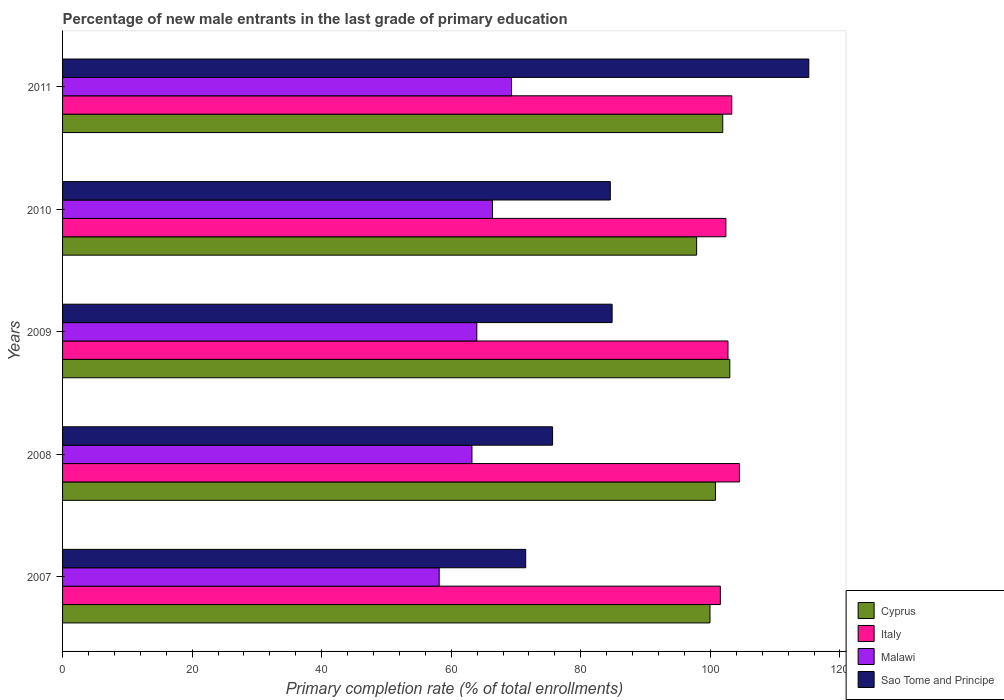How many different coloured bars are there?
Your response must be concise. 4. Are the number of bars per tick equal to the number of legend labels?
Your answer should be very brief. Yes. How many bars are there on the 3rd tick from the top?
Your answer should be very brief. 4. How many bars are there on the 3rd tick from the bottom?
Provide a succinct answer. 4. What is the percentage of new male entrants in Italy in 2007?
Keep it short and to the point. 101.54. Across all years, what is the maximum percentage of new male entrants in Sao Tome and Principe?
Offer a terse response. 115.2. Across all years, what is the minimum percentage of new male entrants in Sao Tome and Principe?
Your answer should be very brief. 71.49. In which year was the percentage of new male entrants in Italy minimum?
Your answer should be very brief. 2007. What is the total percentage of new male entrants in Malawi in the graph?
Keep it short and to the point. 320.95. What is the difference between the percentage of new male entrants in Sao Tome and Principe in 2008 and that in 2010?
Provide a short and direct response. -8.92. What is the difference between the percentage of new male entrants in Malawi in 2008 and the percentage of new male entrants in Cyprus in 2007?
Your answer should be very brief. -36.75. What is the average percentage of new male entrants in Cyprus per year?
Give a very brief answer. 100.7. In the year 2008, what is the difference between the percentage of new male entrants in Italy and percentage of new male entrants in Malawi?
Keep it short and to the point. 41.29. In how many years, is the percentage of new male entrants in Malawi greater than 88 %?
Make the answer very short. 0. What is the ratio of the percentage of new male entrants in Malawi in 2010 to that in 2011?
Make the answer very short. 0.96. Is the percentage of new male entrants in Italy in 2008 less than that in 2010?
Ensure brevity in your answer.  No. Is the difference between the percentage of new male entrants in Italy in 2008 and 2009 greater than the difference between the percentage of new male entrants in Malawi in 2008 and 2009?
Offer a very short reply. Yes. What is the difference between the highest and the second highest percentage of new male entrants in Cyprus?
Give a very brief answer. 1.09. What is the difference between the highest and the lowest percentage of new male entrants in Cyprus?
Offer a terse response. 5.12. In how many years, is the percentage of new male entrants in Sao Tome and Principe greater than the average percentage of new male entrants in Sao Tome and Principe taken over all years?
Offer a very short reply. 1. Is the sum of the percentage of new male entrants in Cyprus in 2010 and 2011 greater than the maximum percentage of new male entrants in Sao Tome and Principe across all years?
Offer a very short reply. Yes. What does the 1st bar from the top in 2010 represents?
Offer a very short reply. Sao Tome and Principe. What does the 4th bar from the bottom in 2009 represents?
Offer a terse response. Sao Tome and Principe. How many bars are there?
Your answer should be compact. 20. Are all the bars in the graph horizontal?
Provide a succinct answer. Yes. What is the difference between two consecutive major ticks on the X-axis?
Ensure brevity in your answer.  20. Does the graph contain any zero values?
Give a very brief answer. No. Does the graph contain grids?
Keep it short and to the point. No. How many legend labels are there?
Offer a terse response. 4. What is the title of the graph?
Ensure brevity in your answer.  Percentage of new male entrants in the last grade of primary education. Does "Rwanda" appear as one of the legend labels in the graph?
Keep it short and to the point. No. What is the label or title of the X-axis?
Your response must be concise. Primary completion rate (% of total enrollments). What is the label or title of the Y-axis?
Your answer should be very brief. Years. What is the Primary completion rate (% of total enrollments) in Cyprus in 2007?
Your answer should be compact. 99.94. What is the Primary completion rate (% of total enrollments) of Italy in 2007?
Ensure brevity in your answer.  101.54. What is the Primary completion rate (% of total enrollments) of Malawi in 2007?
Provide a short and direct response. 58.14. What is the Primary completion rate (% of total enrollments) in Sao Tome and Principe in 2007?
Keep it short and to the point. 71.49. What is the Primary completion rate (% of total enrollments) of Cyprus in 2008?
Provide a succinct answer. 100.79. What is the Primary completion rate (% of total enrollments) of Italy in 2008?
Provide a succinct answer. 104.49. What is the Primary completion rate (% of total enrollments) in Malawi in 2008?
Ensure brevity in your answer.  63.2. What is the Primary completion rate (% of total enrollments) in Sao Tome and Principe in 2008?
Your answer should be very brief. 75.64. What is the Primary completion rate (% of total enrollments) of Cyprus in 2009?
Give a very brief answer. 103. What is the Primary completion rate (% of total enrollments) of Italy in 2009?
Make the answer very short. 102.72. What is the Primary completion rate (% of total enrollments) of Malawi in 2009?
Give a very brief answer. 63.95. What is the Primary completion rate (% of total enrollments) in Sao Tome and Principe in 2009?
Provide a short and direct response. 84.83. What is the Primary completion rate (% of total enrollments) of Cyprus in 2010?
Give a very brief answer. 97.88. What is the Primary completion rate (% of total enrollments) in Italy in 2010?
Provide a short and direct response. 102.4. What is the Primary completion rate (% of total enrollments) in Malawi in 2010?
Your answer should be very brief. 66.37. What is the Primary completion rate (% of total enrollments) of Sao Tome and Principe in 2010?
Your answer should be very brief. 84.56. What is the Primary completion rate (% of total enrollments) in Cyprus in 2011?
Provide a short and direct response. 101.91. What is the Primary completion rate (% of total enrollments) in Italy in 2011?
Keep it short and to the point. 103.31. What is the Primary completion rate (% of total enrollments) in Malawi in 2011?
Offer a terse response. 69.3. What is the Primary completion rate (% of total enrollments) of Sao Tome and Principe in 2011?
Give a very brief answer. 115.2. Across all years, what is the maximum Primary completion rate (% of total enrollments) in Cyprus?
Ensure brevity in your answer.  103. Across all years, what is the maximum Primary completion rate (% of total enrollments) in Italy?
Make the answer very short. 104.49. Across all years, what is the maximum Primary completion rate (% of total enrollments) in Malawi?
Give a very brief answer. 69.3. Across all years, what is the maximum Primary completion rate (% of total enrollments) in Sao Tome and Principe?
Offer a terse response. 115.2. Across all years, what is the minimum Primary completion rate (% of total enrollments) of Cyprus?
Keep it short and to the point. 97.88. Across all years, what is the minimum Primary completion rate (% of total enrollments) in Italy?
Provide a short and direct response. 101.54. Across all years, what is the minimum Primary completion rate (% of total enrollments) in Malawi?
Offer a very short reply. 58.14. Across all years, what is the minimum Primary completion rate (% of total enrollments) in Sao Tome and Principe?
Make the answer very short. 71.49. What is the total Primary completion rate (% of total enrollments) of Cyprus in the graph?
Offer a very short reply. 503.52. What is the total Primary completion rate (% of total enrollments) in Italy in the graph?
Your response must be concise. 514.46. What is the total Primary completion rate (% of total enrollments) in Malawi in the graph?
Keep it short and to the point. 320.95. What is the total Primary completion rate (% of total enrollments) of Sao Tome and Principe in the graph?
Make the answer very short. 431.73. What is the difference between the Primary completion rate (% of total enrollments) of Cyprus in 2007 and that in 2008?
Make the answer very short. -0.84. What is the difference between the Primary completion rate (% of total enrollments) in Italy in 2007 and that in 2008?
Give a very brief answer. -2.95. What is the difference between the Primary completion rate (% of total enrollments) in Malawi in 2007 and that in 2008?
Offer a terse response. -5.06. What is the difference between the Primary completion rate (% of total enrollments) in Sao Tome and Principe in 2007 and that in 2008?
Your answer should be very brief. -4.15. What is the difference between the Primary completion rate (% of total enrollments) of Cyprus in 2007 and that in 2009?
Offer a very short reply. -3.06. What is the difference between the Primary completion rate (% of total enrollments) in Italy in 2007 and that in 2009?
Your response must be concise. -1.18. What is the difference between the Primary completion rate (% of total enrollments) in Malawi in 2007 and that in 2009?
Provide a short and direct response. -5.81. What is the difference between the Primary completion rate (% of total enrollments) in Sao Tome and Principe in 2007 and that in 2009?
Give a very brief answer. -13.34. What is the difference between the Primary completion rate (% of total enrollments) of Cyprus in 2007 and that in 2010?
Offer a very short reply. 2.06. What is the difference between the Primary completion rate (% of total enrollments) of Italy in 2007 and that in 2010?
Offer a very short reply. -0.85. What is the difference between the Primary completion rate (% of total enrollments) in Malawi in 2007 and that in 2010?
Your answer should be very brief. -8.23. What is the difference between the Primary completion rate (% of total enrollments) of Sao Tome and Principe in 2007 and that in 2010?
Provide a short and direct response. -13.06. What is the difference between the Primary completion rate (% of total enrollments) of Cyprus in 2007 and that in 2011?
Ensure brevity in your answer.  -1.97. What is the difference between the Primary completion rate (% of total enrollments) of Italy in 2007 and that in 2011?
Your response must be concise. -1.76. What is the difference between the Primary completion rate (% of total enrollments) in Malawi in 2007 and that in 2011?
Your answer should be very brief. -11.16. What is the difference between the Primary completion rate (% of total enrollments) of Sao Tome and Principe in 2007 and that in 2011?
Offer a terse response. -43.7. What is the difference between the Primary completion rate (% of total enrollments) of Cyprus in 2008 and that in 2009?
Provide a succinct answer. -2.22. What is the difference between the Primary completion rate (% of total enrollments) in Italy in 2008 and that in 2009?
Offer a very short reply. 1.77. What is the difference between the Primary completion rate (% of total enrollments) of Malawi in 2008 and that in 2009?
Provide a succinct answer. -0.75. What is the difference between the Primary completion rate (% of total enrollments) of Sao Tome and Principe in 2008 and that in 2009?
Your response must be concise. -9.19. What is the difference between the Primary completion rate (% of total enrollments) in Cyprus in 2008 and that in 2010?
Make the answer very short. 2.91. What is the difference between the Primary completion rate (% of total enrollments) of Italy in 2008 and that in 2010?
Make the answer very short. 2.09. What is the difference between the Primary completion rate (% of total enrollments) of Malawi in 2008 and that in 2010?
Offer a terse response. -3.17. What is the difference between the Primary completion rate (% of total enrollments) in Sao Tome and Principe in 2008 and that in 2010?
Your answer should be very brief. -8.92. What is the difference between the Primary completion rate (% of total enrollments) in Cyprus in 2008 and that in 2011?
Give a very brief answer. -1.12. What is the difference between the Primary completion rate (% of total enrollments) of Italy in 2008 and that in 2011?
Make the answer very short. 1.18. What is the difference between the Primary completion rate (% of total enrollments) in Malawi in 2008 and that in 2011?
Offer a terse response. -6.1. What is the difference between the Primary completion rate (% of total enrollments) in Sao Tome and Principe in 2008 and that in 2011?
Offer a very short reply. -39.55. What is the difference between the Primary completion rate (% of total enrollments) in Cyprus in 2009 and that in 2010?
Offer a very short reply. 5.12. What is the difference between the Primary completion rate (% of total enrollments) in Italy in 2009 and that in 2010?
Offer a terse response. 0.32. What is the difference between the Primary completion rate (% of total enrollments) in Malawi in 2009 and that in 2010?
Offer a terse response. -2.42. What is the difference between the Primary completion rate (% of total enrollments) in Sao Tome and Principe in 2009 and that in 2010?
Give a very brief answer. 0.28. What is the difference between the Primary completion rate (% of total enrollments) of Cyprus in 2009 and that in 2011?
Your answer should be compact. 1.09. What is the difference between the Primary completion rate (% of total enrollments) in Italy in 2009 and that in 2011?
Keep it short and to the point. -0.59. What is the difference between the Primary completion rate (% of total enrollments) of Malawi in 2009 and that in 2011?
Offer a terse response. -5.35. What is the difference between the Primary completion rate (% of total enrollments) in Sao Tome and Principe in 2009 and that in 2011?
Your answer should be very brief. -30.36. What is the difference between the Primary completion rate (% of total enrollments) of Cyprus in 2010 and that in 2011?
Your answer should be very brief. -4.03. What is the difference between the Primary completion rate (% of total enrollments) of Italy in 2010 and that in 2011?
Keep it short and to the point. -0.91. What is the difference between the Primary completion rate (% of total enrollments) of Malawi in 2010 and that in 2011?
Offer a terse response. -2.93. What is the difference between the Primary completion rate (% of total enrollments) in Sao Tome and Principe in 2010 and that in 2011?
Your answer should be very brief. -30.64. What is the difference between the Primary completion rate (% of total enrollments) in Cyprus in 2007 and the Primary completion rate (% of total enrollments) in Italy in 2008?
Offer a terse response. -4.54. What is the difference between the Primary completion rate (% of total enrollments) of Cyprus in 2007 and the Primary completion rate (% of total enrollments) of Malawi in 2008?
Your answer should be compact. 36.75. What is the difference between the Primary completion rate (% of total enrollments) of Cyprus in 2007 and the Primary completion rate (% of total enrollments) of Sao Tome and Principe in 2008?
Your answer should be very brief. 24.3. What is the difference between the Primary completion rate (% of total enrollments) in Italy in 2007 and the Primary completion rate (% of total enrollments) in Malawi in 2008?
Your answer should be very brief. 38.35. What is the difference between the Primary completion rate (% of total enrollments) in Italy in 2007 and the Primary completion rate (% of total enrollments) in Sao Tome and Principe in 2008?
Offer a very short reply. 25.9. What is the difference between the Primary completion rate (% of total enrollments) in Malawi in 2007 and the Primary completion rate (% of total enrollments) in Sao Tome and Principe in 2008?
Your answer should be compact. -17.51. What is the difference between the Primary completion rate (% of total enrollments) in Cyprus in 2007 and the Primary completion rate (% of total enrollments) in Italy in 2009?
Make the answer very short. -2.78. What is the difference between the Primary completion rate (% of total enrollments) of Cyprus in 2007 and the Primary completion rate (% of total enrollments) of Malawi in 2009?
Provide a succinct answer. 36. What is the difference between the Primary completion rate (% of total enrollments) of Cyprus in 2007 and the Primary completion rate (% of total enrollments) of Sao Tome and Principe in 2009?
Ensure brevity in your answer.  15.11. What is the difference between the Primary completion rate (% of total enrollments) in Italy in 2007 and the Primary completion rate (% of total enrollments) in Malawi in 2009?
Your answer should be very brief. 37.59. What is the difference between the Primary completion rate (% of total enrollments) in Italy in 2007 and the Primary completion rate (% of total enrollments) in Sao Tome and Principe in 2009?
Keep it short and to the point. 16.71. What is the difference between the Primary completion rate (% of total enrollments) of Malawi in 2007 and the Primary completion rate (% of total enrollments) of Sao Tome and Principe in 2009?
Ensure brevity in your answer.  -26.7. What is the difference between the Primary completion rate (% of total enrollments) of Cyprus in 2007 and the Primary completion rate (% of total enrollments) of Italy in 2010?
Provide a short and direct response. -2.45. What is the difference between the Primary completion rate (% of total enrollments) of Cyprus in 2007 and the Primary completion rate (% of total enrollments) of Malawi in 2010?
Your answer should be very brief. 33.58. What is the difference between the Primary completion rate (% of total enrollments) in Cyprus in 2007 and the Primary completion rate (% of total enrollments) in Sao Tome and Principe in 2010?
Your answer should be compact. 15.39. What is the difference between the Primary completion rate (% of total enrollments) of Italy in 2007 and the Primary completion rate (% of total enrollments) of Malawi in 2010?
Offer a very short reply. 35.17. What is the difference between the Primary completion rate (% of total enrollments) in Italy in 2007 and the Primary completion rate (% of total enrollments) in Sao Tome and Principe in 2010?
Give a very brief answer. 16.98. What is the difference between the Primary completion rate (% of total enrollments) of Malawi in 2007 and the Primary completion rate (% of total enrollments) of Sao Tome and Principe in 2010?
Make the answer very short. -26.42. What is the difference between the Primary completion rate (% of total enrollments) in Cyprus in 2007 and the Primary completion rate (% of total enrollments) in Italy in 2011?
Offer a terse response. -3.36. What is the difference between the Primary completion rate (% of total enrollments) in Cyprus in 2007 and the Primary completion rate (% of total enrollments) in Malawi in 2011?
Ensure brevity in your answer.  30.64. What is the difference between the Primary completion rate (% of total enrollments) of Cyprus in 2007 and the Primary completion rate (% of total enrollments) of Sao Tome and Principe in 2011?
Provide a succinct answer. -15.25. What is the difference between the Primary completion rate (% of total enrollments) of Italy in 2007 and the Primary completion rate (% of total enrollments) of Malawi in 2011?
Ensure brevity in your answer.  32.24. What is the difference between the Primary completion rate (% of total enrollments) of Italy in 2007 and the Primary completion rate (% of total enrollments) of Sao Tome and Principe in 2011?
Give a very brief answer. -13.65. What is the difference between the Primary completion rate (% of total enrollments) of Malawi in 2007 and the Primary completion rate (% of total enrollments) of Sao Tome and Principe in 2011?
Provide a short and direct response. -57.06. What is the difference between the Primary completion rate (% of total enrollments) of Cyprus in 2008 and the Primary completion rate (% of total enrollments) of Italy in 2009?
Offer a very short reply. -1.93. What is the difference between the Primary completion rate (% of total enrollments) in Cyprus in 2008 and the Primary completion rate (% of total enrollments) in Malawi in 2009?
Ensure brevity in your answer.  36.84. What is the difference between the Primary completion rate (% of total enrollments) of Cyprus in 2008 and the Primary completion rate (% of total enrollments) of Sao Tome and Principe in 2009?
Make the answer very short. 15.95. What is the difference between the Primary completion rate (% of total enrollments) in Italy in 2008 and the Primary completion rate (% of total enrollments) in Malawi in 2009?
Make the answer very short. 40.54. What is the difference between the Primary completion rate (% of total enrollments) of Italy in 2008 and the Primary completion rate (% of total enrollments) of Sao Tome and Principe in 2009?
Make the answer very short. 19.65. What is the difference between the Primary completion rate (% of total enrollments) of Malawi in 2008 and the Primary completion rate (% of total enrollments) of Sao Tome and Principe in 2009?
Your response must be concise. -21.64. What is the difference between the Primary completion rate (% of total enrollments) in Cyprus in 2008 and the Primary completion rate (% of total enrollments) in Italy in 2010?
Provide a succinct answer. -1.61. What is the difference between the Primary completion rate (% of total enrollments) of Cyprus in 2008 and the Primary completion rate (% of total enrollments) of Malawi in 2010?
Your answer should be compact. 34.42. What is the difference between the Primary completion rate (% of total enrollments) of Cyprus in 2008 and the Primary completion rate (% of total enrollments) of Sao Tome and Principe in 2010?
Make the answer very short. 16.23. What is the difference between the Primary completion rate (% of total enrollments) in Italy in 2008 and the Primary completion rate (% of total enrollments) in Malawi in 2010?
Provide a short and direct response. 38.12. What is the difference between the Primary completion rate (% of total enrollments) of Italy in 2008 and the Primary completion rate (% of total enrollments) of Sao Tome and Principe in 2010?
Your answer should be very brief. 19.93. What is the difference between the Primary completion rate (% of total enrollments) in Malawi in 2008 and the Primary completion rate (% of total enrollments) in Sao Tome and Principe in 2010?
Keep it short and to the point. -21.36. What is the difference between the Primary completion rate (% of total enrollments) in Cyprus in 2008 and the Primary completion rate (% of total enrollments) in Italy in 2011?
Your answer should be compact. -2.52. What is the difference between the Primary completion rate (% of total enrollments) of Cyprus in 2008 and the Primary completion rate (% of total enrollments) of Malawi in 2011?
Your answer should be compact. 31.49. What is the difference between the Primary completion rate (% of total enrollments) of Cyprus in 2008 and the Primary completion rate (% of total enrollments) of Sao Tome and Principe in 2011?
Make the answer very short. -14.41. What is the difference between the Primary completion rate (% of total enrollments) of Italy in 2008 and the Primary completion rate (% of total enrollments) of Malawi in 2011?
Offer a very short reply. 35.19. What is the difference between the Primary completion rate (% of total enrollments) in Italy in 2008 and the Primary completion rate (% of total enrollments) in Sao Tome and Principe in 2011?
Offer a terse response. -10.71. What is the difference between the Primary completion rate (% of total enrollments) of Malawi in 2008 and the Primary completion rate (% of total enrollments) of Sao Tome and Principe in 2011?
Your answer should be very brief. -52. What is the difference between the Primary completion rate (% of total enrollments) of Cyprus in 2009 and the Primary completion rate (% of total enrollments) of Italy in 2010?
Offer a very short reply. 0.6. What is the difference between the Primary completion rate (% of total enrollments) of Cyprus in 2009 and the Primary completion rate (% of total enrollments) of Malawi in 2010?
Provide a short and direct response. 36.63. What is the difference between the Primary completion rate (% of total enrollments) in Cyprus in 2009 and the Primary completion rate (% of total enrollments) in Sao Tome and Principe in 2010?
Offer a terse response. 18.44. What is the difference between the Primary completion rate (% of total enrollments) of Italy in 2009 and the Primary completion rate (% of total enrollments) of Malawi in 2010?
Give a very brief answer. 36.35. What is the difference between the Primary completion rate (% of total enrollments) in Italy in 2009 and the Primary completion rate (% of total enrollments) in Sao Tome and Principe in 2010?
Make the answer very short. 18.16. What is the difference between the Primary completion rate (% of total enrollments) of Malawi in 2009 and the Primary completion rate (% of total enrollments) of Sao Tome and Principe in 2010?
Provide a succinct answer. -20.61. What is the difference between the Primary completion rate (% of total enrollments) in Cyprus in 2009 and the Primary completion rate (% of total enrollments) in Italy in 2011?
Provide a short and direct response. -0.31. What is the difference between the Primary completion rate (% of total enrollments) of Cyprus in 2009 and the Primary completion rate (% of total enrollments) of Malawi in 2011?
Give a very brief answer. 33.7. What is the difference between the Primary completion rate (% of total enrollments) of Cyprus in 2009 and the Primary completion rate (% of total enrollments) of Sao Tome and Principe in 2011?
Provide a succinct answer. -12.19. What is the difference between the Primary completion rate (% of total enrollments) of Italy in 2009 and the Primary completion rate (% of total enrollments) of Malawi in 2011?
Provide a short and direct response. 33.42. What is the difference between the Primary completion rate (% of total enrollments) in Italy in 2009 and the Primary completion rate (% of total enrollments) in Sao Tome and Principe in 2011?
Ensure brevity in your answer.  -12.48. What is the difference between the Primary completion rate (% of total enrollments) in Malawi in 2009 and the Primary completion rate (% of total enrollments) in Sao Tome and Principe in 2011?
Make the answer very short. -51.25. What is the difference between the Primary completion rate (% of total enrollments) of Cyprus in 2010 and the Primary completion rate (% of total enrollments) of Italy in 2011?
Ensure brevity in your answer.  -5.43. What is the difference between the Primary completion rate (% of total enrollments) of Cyprus in 2010 and the Primary completion rate (% of total enrollments) of Malawi in 2011?
Your response must be concise. 28.58. What is the difference between the Primary completion rate (% of total enrollments) of Cyprus in 2010 and the Primary completion rate (% of total enrollments) of Sao Tome and Principe in 2011?
Give a very brief answer. -17.32. What is the difference between the Primary completion rate (% of total enrollments) in Italy in 2010 and the Primary completion rate (% of total enrollments) in Malawi in 2011?
Ensure brevity in your answer.  33.1. What is the difference between the Primary completion rate (% of total enrollments) of Italy in 2010 and the Primary completion rate (% of total enrollments) of Sao Tome and Principe in 2011?
Provide a succinct answer. -12.8. What is the difference between the Primary completion rate (% of total enrollments) in Malawi in 2010 and the Primary completion rate (% of total enrollments) in Sao Tome and Principe in 2011?
Offer a terse response. -48.83. What is the average Primary completion rate (% of total enrollments) of Cyprus per year?
Provide a succinct answer. 100.7. What is the average Primary completion rate (% of total enrollments) in Italy per year?
Provide a short and direct response. 102.89. What is the average Primary completion rate (% of total enrollments) in Malawi per year?
Offer a very short reply. 64.19. What is the average Primary completion rate (% of total enrollments) in Sao Tome and Principe per year?
Make the answer very short. 86.35. In the year 2007, what is the difference between the Primary completion rate (% of total enrollments) in Cyprus and Primary completion rate (% of total enrollments) in Italy?
Make the answer very short. -1.6. In the year 2007, what is the difference between the Primary completion rate (% of total enrollments) of Cyprus and Primary completion rate (% of total enrollments) of Malawi?
Provide a short and direct response. 41.81. In the year 2007, what is the difference between the Primary completion rate (% of total enrollments) of Cyprus and Primary completion rate (% of total enrollments) of Sao Tome and Principe?
Make the answer very short. 28.45. In the year 2007, what is the difference between the Primary completion rate (% of total enrollments) of Italy and Primary completion rate (% of total enrollments) of Malawi?
Make the answer very short. 43.41. In the year 2007, what is the difference between the Primary completion rate (% of total enrollments) in Italy and Primary completion rate (% of total enrollments) in Sao Tome and Principe?
Your response must be concise. 30.05. In the year 2007, what is the difference between the Primary completion rate (% of total enrollments) in Malawi and Primary completion rate (% of total enrollments) in Sao Tome and Principe?
Your answer should be very brief. -13.36. In the year 2008, what is the difference between the Primary completion rate (% of total enrollments) in Cyprus and Primary completion rate (% of total enrollments) in Italy?
Ensure brevity in your answer.  -3.7. In the year 2008, what is the difference between the Primary completion rate (% of total enrollments) of Cyprus and Primary completion rate (% of total enrollments) of Malawi?
Make the answer very short. 37.59. In the year 2008, what is the difference between the Primary completion rate (% of total enrollments) of Cyprus and Primary completion rate (% of total enrollments) of Sao Tome and Principe?
Your response must be concise. 25.14. In the year 2008, what is the difference between the Primary completion rate (% of total enrollments) in Italy and Primary completion rate (% of total enrollments) in Malawi?
Offer a terse response. 41.29. In the year 2008, what is the difference between the Primary completion rate (% of total enrollments) in Italy and Primary completion rate (% of total enrollments) in Sao Tome and Principe?
Your answer should be compact. 28.85. In the year 2008, what is the difference between the Primary completion rate (% of total enrollments) of Malawi and Primary completion rate (% of total enrollments) of Sao Tome and Principe?
Your answer should be compact. -12.45. In the year 2009, what is the difference between the Primary completion rate (% of total enrollments) of Cyprus and Primary completion rate (% of total enrollments) of Italy?
Make the answer very short. 0.28. In the year 2009, what is the difference between the Primary completion rate (% of total enrollments) of Cyprus and Primary completion rate (% of total enrollments) of Malawi?
Offer a very short reply. 39.05. In the year 2009, what is the difference between the Primary completion rate (% of total enrollments) of Cyprus and Primary completion rate (% of total enrollments) of Sao Tome and Principe?
Provide a succinct answer. 18.17. In the year 2009, what is the difference between the Primary completion rate (% of total enrollments) of Italy and Primary completion rate (% of total enrollments) of Malawi?
Ensure brevity in your answer.  38.77. In the year 2009, what is the difference between the Primary completion rate (% of total enrollments) in Italy and Primary completion rate (% of total enrollments) in Sao Tome and Principe?
Offer a very short reply. 17.89. In the year 2009, what is the difference between the Primary completion rate (% of total enrollments) of Malawi and Primary completion rate (% of total enrollments) of Sao Tome and Principe?
Make the answer very short. -20.89. In the year 2010, what is the difference between the Primary completion rate (% of total enrollments) in Cyprus and Primary completion rate (% of total enrollments) in Italy?
Keep it short and to the point. -4.52. In the year 2010, what is the difference between the Primary completion rate (% of total enrollments) in Cyprus and Primary completion rate (% of total enrollments) in Malawi?
Your answer should be compact. 31.51. In the year 2010, what is the difference between the Primary completion rate (% of total enrollments) of Cyprus and Primary completion rate (% of total enrollments) of Sao Tome and Principe?
Give a very brief answer. 13.32. In the year 2010, what is the difference between the Primary completion rate (% of total enrollments) of Italy and Primary completion rate (% of total enrollments) of Malawi?
Offer a terse response. 36.03. In the year 2010, what is the difference between the Primary completion rate (% of total enrollments) of Italy and Primary completion rate (% of total enrollments) of Sao Tome and Principe?
Offer a very short reply. 17.84. In the year 2010, what is the difference between the Primary completion rate (% of total enrollments) in Malawi and Primary completion rate (% of total enrollments) in Sao Tome and Principe?
Offer a very short reply. -18.19. In the year 2011, what is the difference between the Primary completion rate (% of total enrollments) of Cyprus and Primary completion rate (% of total enrollments) of Italy?
Give a very brief answer. -1.4. In the year 2011, what is the difference between the Primary completion rate (% of total enrollments) in Cyprus and Primary completion rate (% of total enrollments) in Malawi?
Make the answer very short. 32.61. In the year 2011, what is the difference between the Primary completion rate (% of total enrollments) in Cyprus and Primary completion rate (% of total enrollments) in Sao Tome and Principe?
Make the answer very short. -13.29. In the year 2011, what is the difference between the Primary completion rate (% of total enrollments) in Italy and Primary completion rate (% of total enrollments) in Malawi?
Provide a short and direct response. 34.01. In the year 2011, what is the difference between the Primary completion rate (% of total enrollments) of Italy and Primary completion rate (% of total enrollments) of Sao Tome and Principe?
Your response must be concise. -11.89. In the year 2011, what is the difference between the Primary completion rate (% of total enrollments) of Malawi and Primary completion rate (% of total enrollments) of Sao Tome and Principe?
Keep it short and to the point. -45.9. What is the ratio of the Primary completion rate (% of total enrollments) of Cyprus in 2007 to that in 2008?
Offer a terse response. 0.99. What is the ratio of the Primary completion rate (% of total enrollments) of Italy in 2007 to that in 2008?
Your response must be concise. 0.97. What is the ratio of the Primary completion rate (% of total enrollments) of Malawi in 2007 to that in 2008?
Offer a terse response. 0.92. What is the ratio of the Primary completion rate (% of total enrollments) in Sao Tome and Principe in 2007 to that in 2008?
Provide a short and direct response. 0.95. What is the ratio of the Primary completion rate (% of total enrollments) in Cyprus in 2007 to that in 2009?
Offer a very short reply. 0.97. What is the ratio of the Primary completion rate (% of total enrollments) in Italy in 2007 to that in 2009?
Make the answer very short. 0.99. What is the ratio of the Primary completion rate (% of total enrollments) of Malawi in 2007 to that in 2009?
Make the answer very short. 0.91. What is the ratio of the Primary completion rate (% of total enrollments) of Sao Tome and Principe in 2007 to that in 2009?
Give a very brief answer. 0.84. What is the ratio of the Primary completion rate (% of total enrollments) of Cyprus in 2007 to that in 2010?
Make the answer very short. 1.02. What is the ratio of the Primary completion rate (% of total enrollments) of Malawi in 2007 to that in 2010?
Offer a terse response. 0.88. What is the ratio of the Primary completion rate (% of total enrollments) of Sao Tome and Principe in 2007 to that in 2010?
Offer a very short reply. 0.85. What is the ratio of the Primary completion rate (% of total enrollments) of Cyprus in 2007 to that in 2011?
Your answer should be compact. 0.98. What is the ratio of the Primary completion rate (% of total enrollments) in Italy in 2007 to that in 2011?
Ensure brevity in your answer.  0.98. What is the ratio of the Primary completion rate (% of total enrollments) of Malawi in 2007 to that in 2011?
Keep it short and to the point. 0.84. What is the ratio of the Primary completion rate (% of total enrollments) in Sao Tome and Principe in 2007 to that in 2011?
Your response must be concise. 0.62. What is the ratio of the Primary completion rate (% of total enrollments) of Cyprus in 2008 to that in 2009?
Offer a terse response. 0.98. What is the ratio of the Primary completion rate (% of total enrollments) in Italy in 2008 to that in 2009?
Provide a short and direct response. 1.02. What is the ratio of the Primary completion rate (% of total enrollments) in Sao Tome and Principe in 2008 to that in 2009?
Give a very brief answer. 0.89. What is the ratio of the Primary completion rate (% of total enrollments) of Cyprus in 2008 to that in 2010?
Offer a very short reply. 1.03. What is the ratio of the Primary completion rate (% of total enrollments) in Italy in 2008 to that in 2010?
Offer a very short reply. 1.02. What is the ratio of the Primary completion rate (% of total enrollments) of Malawi in 2008 to that in 2010?
Offer a terse response. 0.95. What is the ratio of the Primary completion rate (% of total enrollments) in Sao Tome and Principe in 2008 to that in 2010?
Your answer should be very brief. 0.89. What is the ratio of the Primary completion rate (% of total enrollments) in Italy in 2008 to that in 2011?
Provide a short and direct response. 1.01. What is the ratio of the Primary completion rate (% of total enrollments) in Malawi in 2008 to that in 2011?
Provide a succinct answer. 0.91. What is the ratio of the Primary completion rate (% of total enrollments) in Sao Tome and Principe in 2008 to that in 2011?
Provide a short and direct response. 0.66. What is the ratio of the Primary completion rate (% of total enrollments) in Cyprus in 2009 to that in 2010?
Keep it short and to the point. 1.05. What is the ratio of the Primary completion rate (% of total enrollments) in Malawi in 2009 to that in 2010?
Provide a succinct answer. 0.96. What is the ratio of the Primary completion rate (% of total enrollments) in Sao Tome and Principe in 2009 to that in 2010?
Offer a very short reply. 1. What is the ratio of the Primary completion rate (% of total enrollments) of Cyprus in 2009 to that in 2011?
Keep it short and to the point. 1.01. What is the ratio of the Primary completion rate (% of total enrollments) of Italy in 2009 to that in 2011?
Your answer should be very brief. 0.99. What is the ratio of the Primary completion rate (% of total enrollments) of Malawi in 2009 to that in 2011?
Give a very brief answer. 0.92. What is the ratio of the Primary completion rate (% of total enrollments) of Sao Tome and Principe in 2009 to that in 2011?
Offer a very short reply. 0.74. What is the ratio of the Primary completion rate (% of total enrollments) in Cyprus in 2010 to that in 2011?
Offer a terse response. 0.96. What is the ratio of the Primary completion rate (% of total enrollments) of Malawi in 2010 to that in 2011?
Your answer should be very brief. 0.96. What is the ratio of the Primary completion rate (% of total enrollments) of Sao Tome and Principe in 2010 to that in 2011?
Make the answer very short. 0.73. What is the difference between the highest and the second highest Primary completion rate (% of total enrollments) of Cyprus?
Provide a succinct answer. 1.09. What is the difference between the highest and the second highest Primary completion rate (% of total enrollments) of Italy?
Make the answer very short. 1.18. What is the difference between the highest and the second highest Primary completion rate (% of total enrollments) in Malawi?
Offer a terse response. 2.93. What is the difference between the highest and the second highest Primary completion rate (% of total enrollments) in Sao Tome and Principe?
Your answer should be compact. 30.36. What is the difference between the highest and the lowest Primary completion rate (% of total enrollments) of Cyprus?
Ensure brevity in your answer.  5.12. What is the difference between the highest and the lowest Primary completion rate (% of total enrollments) of Italy?
Your response must be concise. 2.95. What is the difference between the highest and the lowest Primary completion rate (% of total enrollments) of Malawi?
Give a very brief answer. 11.16. What is the difference between the highest and the lowest Primary completion rate (% of total enrollments) of Sao Tome and Principe?
Keep it short and to the point. 43.7. 